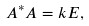<formula> <loc_0><loc_0><loc_500><loc_500>A ^ { * } A = k E ,</formula> 